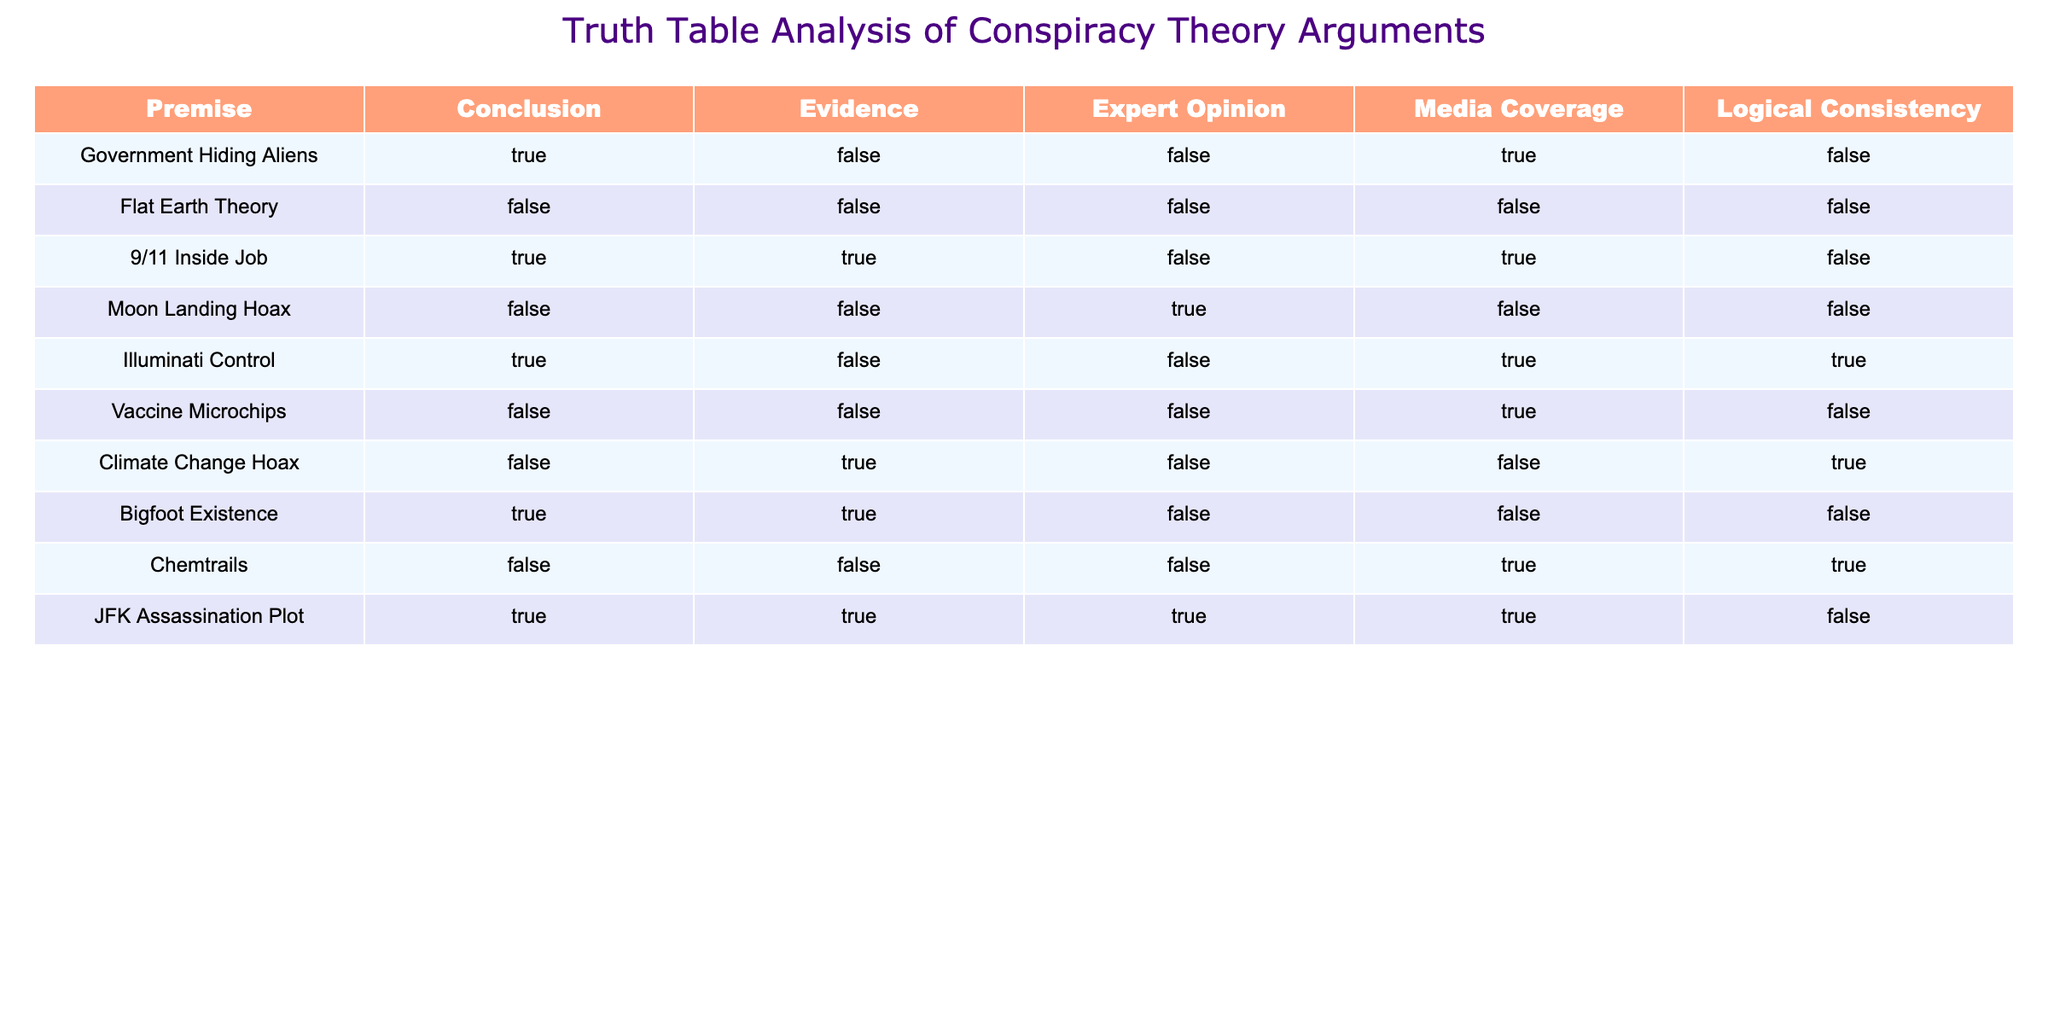What is the premise of the "Vaccine Microchips" theory? The table shows that the premise for "Vaccine Microchips" is listed, and it states that it is "False."
Answer: False How many conspiracy theories have "True" as their conclusion? By reviewing the conclusion column, we can count the number of theories marked as "True." There are 5 theories: "Government Hiding Aliens," "9/11 Inside Job," "Illuminati Control," "Bigfoot Existence," and "JFK Assassination Plot."
Answer: 5 Is there any theory that has both "True" for Evidence and "True" for Expert Opinion? Checking the table, we find "9/11 Inside Job" and "JFK Assassination Plot" as the only entries with both "True" under Evidence and Expert Opinion. Thus, these two fit the criteria.
Answer: Yes What are the logical consistencies of theories that conclude with "True"? We examine the table for the theories with a "True" conclusion: "Government Hiding Aliens," "9/11 Inside Job," "Illuminati Control," "Bigfoot Existence," and "JFK Assassination Plot." Be checking the column for Logical Consistency, we find that only "Illuminati Control" has a "True" logical consistency, while the others do not.
Answer: One Which conspiracy theory has "True" for Media Coverage but "False" for Expert Opinion? Upon reviewing the table, "Government Hiding Aliens" fits this criterion as it has "True" for Media Coverage and "False" for Expert Opinion.
Answer: Government Hiding Aliens How many conspiracy theories have "False" as their conclusion and also have "True" for Evidence? We look for "False" in the Conclusion column. We find "Flat Earth Theory," "Vaccine Microchips," and "Moon Landing Hoax" have "False" conclusions. Among these, only "Climate Change Hoax" has "True" for Evidence, making it the only one.
Answer: 1 What percentage of theories with "True" for Expert Opinion have a "True" conclusion? The theories with "True" for Expert Opinion are "Illuminati Control," "9/11 Inside Job," "JFK Assassination Plot" which are 3 in total. Out of these, "9/11 Inside Job" and "JFK Assassination Plot" also have "True" conclusions, giving us 2 out of 3. The percentage is (2/3) * 100 = 66.67%.
Answer: 66.67% Are there any conspiracy theory arguments that have both "False" for Media Coverage and "True" for Evidence? Reviewing the table, we find "Flat Earth Theory," "Vaccine Microchips," and "Chemtrails", which have "False" for Media Coverage. However, only "Bigfoot Existence" has "True" for Evidence among these.
Answer: Yes 